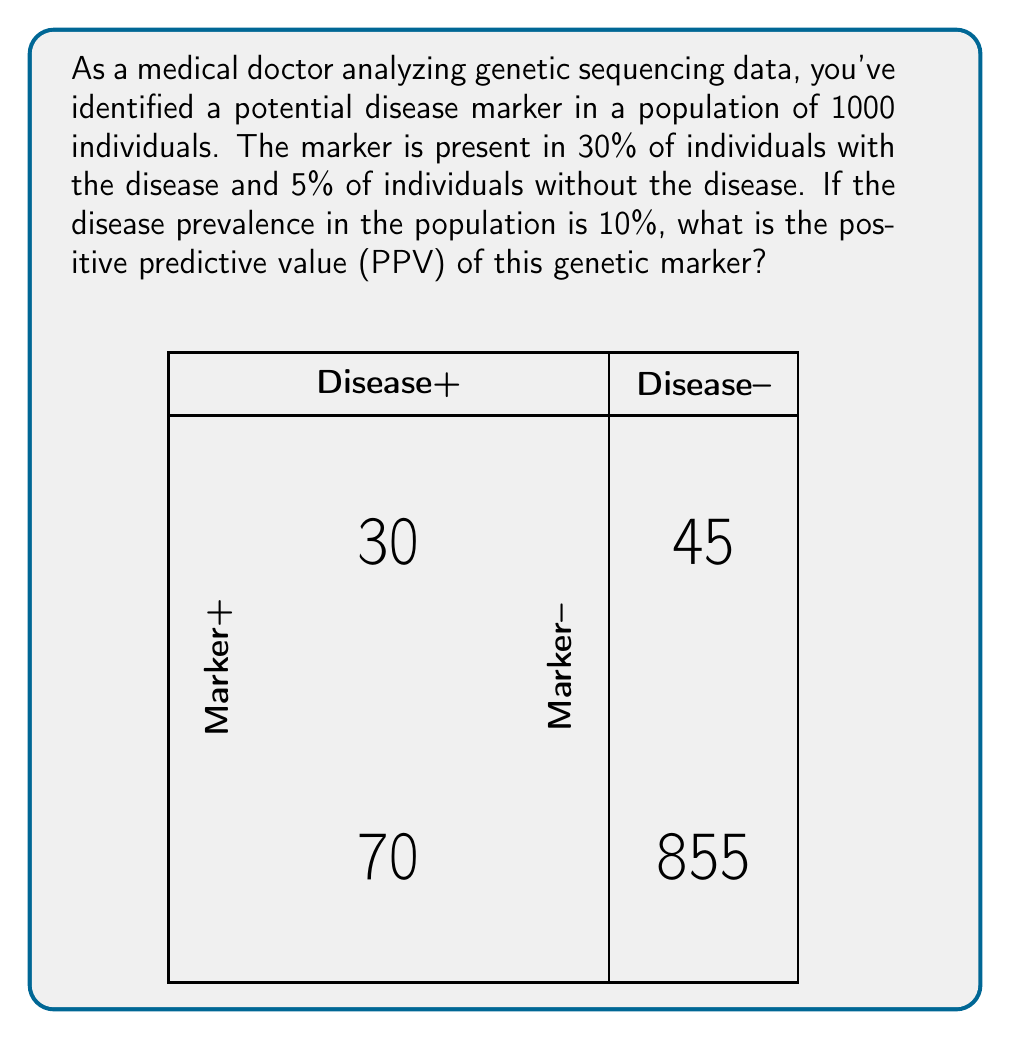Could you help me with this problem? To solve this problem, we'll use Bayes' theorem and the concept of positive predictive value. Let's break it down step-by-step:

1) First, let's define our variables:
   - P(D) = Prevalence of disease = 10% = 0.1
   - P(M|D) = Probability of marker given disease = 30% = 0.3
   - P(M|not D) = Probability of marker given no disease = 5% = 0.05

2) We need to calculate P(D|M), which is the probability of disease given a positive marker (PPV).

3) Bayes' theorem states:

   $$P(D|M) = \frac{P(M|D) \cdot P(D)}{P(M)}$$

4) We know P(M|D) and P(D), but we need to calculate P(M):

   $$P(M) = P(M|D) \cdot P(D) + P(M|not D) \cdot P(not D)$$

5) Calculate P(not D):
   $$P(not D) = 1 - P(D) = 1 - 0.1 = 0.9$$

6) Now we can calculate P(M):
   $$P(M) = 0.3 \cdot 0.1 + 0.05 \cdot 0.9 = 0.03 + 0.045 = 0.075$$

7) Plugging everything into Bayes' theorem:

   $$P(D|M) = \frac{0.3 \cdot 0.1}{0.075} = \frac{0.03}{0.075} = 0.4$$

8) Convert to percentage: 0.4 * 100 = 40%

Therefore, the positive predictive value of this genetic marker is 40%.
Answer: 40% 